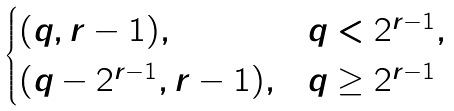Convert formula to latex. <formula><loc_0><loc_0><loc_500><loc_500>\begin{cases} ( q , r - 1 ) , & q < 2 ^ { r - 1 } , \\ ( q - 2 ^ { r - 1 } , r - 1 ) , & q \geq 2 ^ { r - 1 } \end{cases}</formula> 